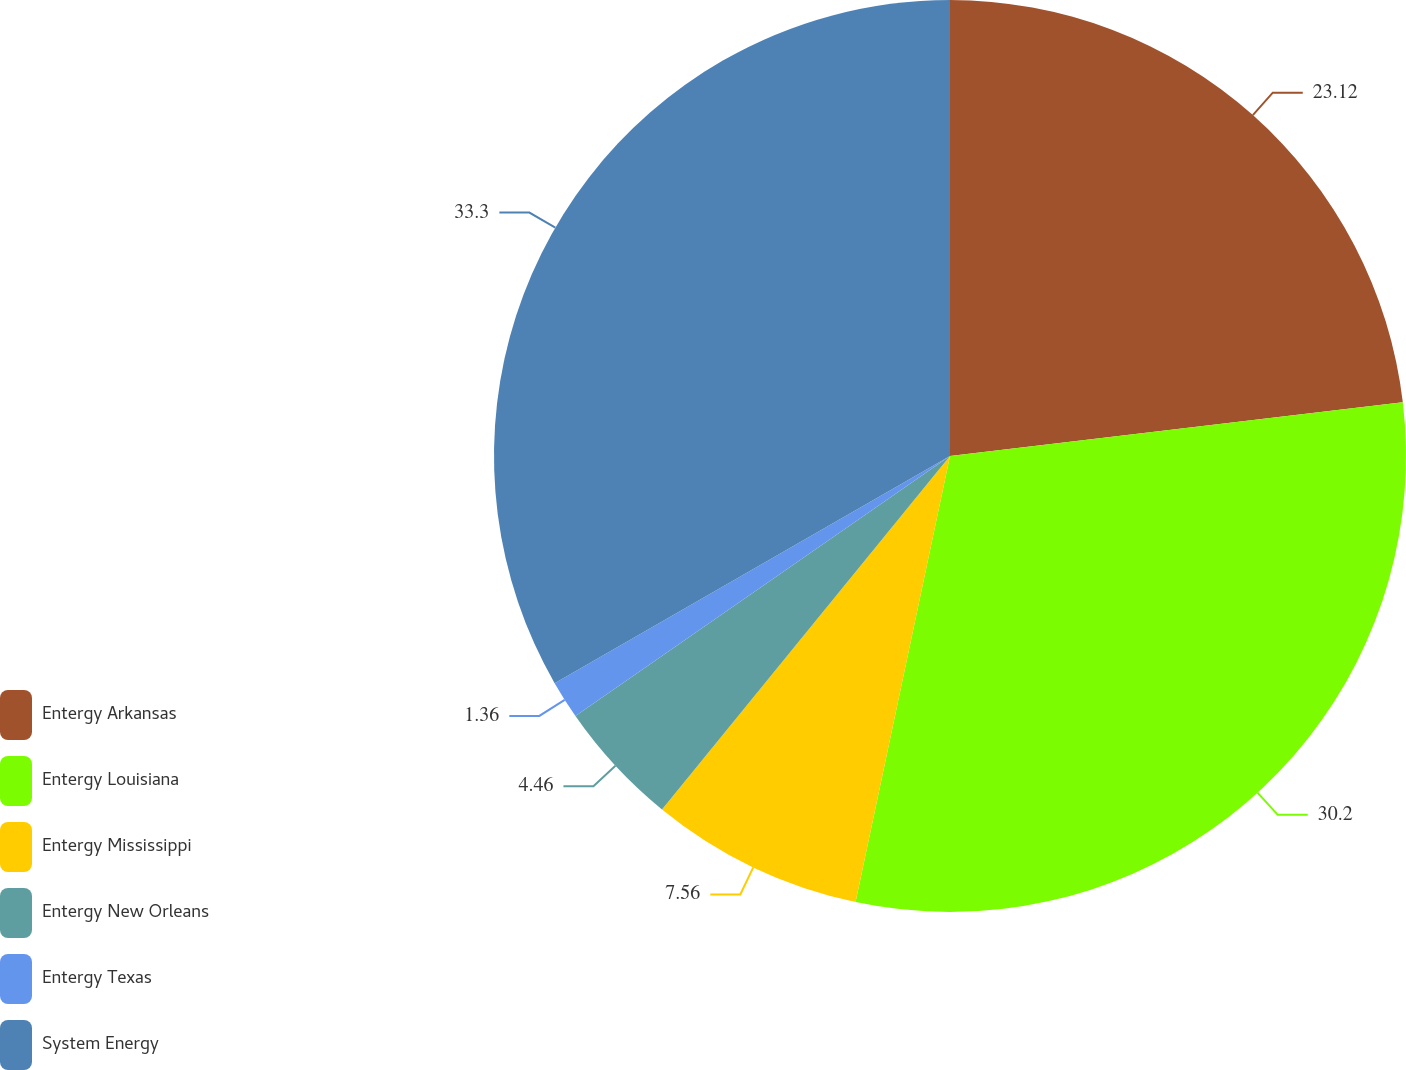Convert chart to OTSL. <chart><loc_0><loc_0><loc_500><loc_500><pie_chart><fcel>Entergy Arkansas<fcel>Entergy Louisiana<fcel>Entergy Mississippi<fcel>Entergy New Orleans<fcel>Entergy Texas<fcel>System Energy<nl><fcel>23.12%<fcel>30.2%<fcel>7.56%<fcel>4.46%<fcel>1.36%<fcel>33.3%<nl></chart> 